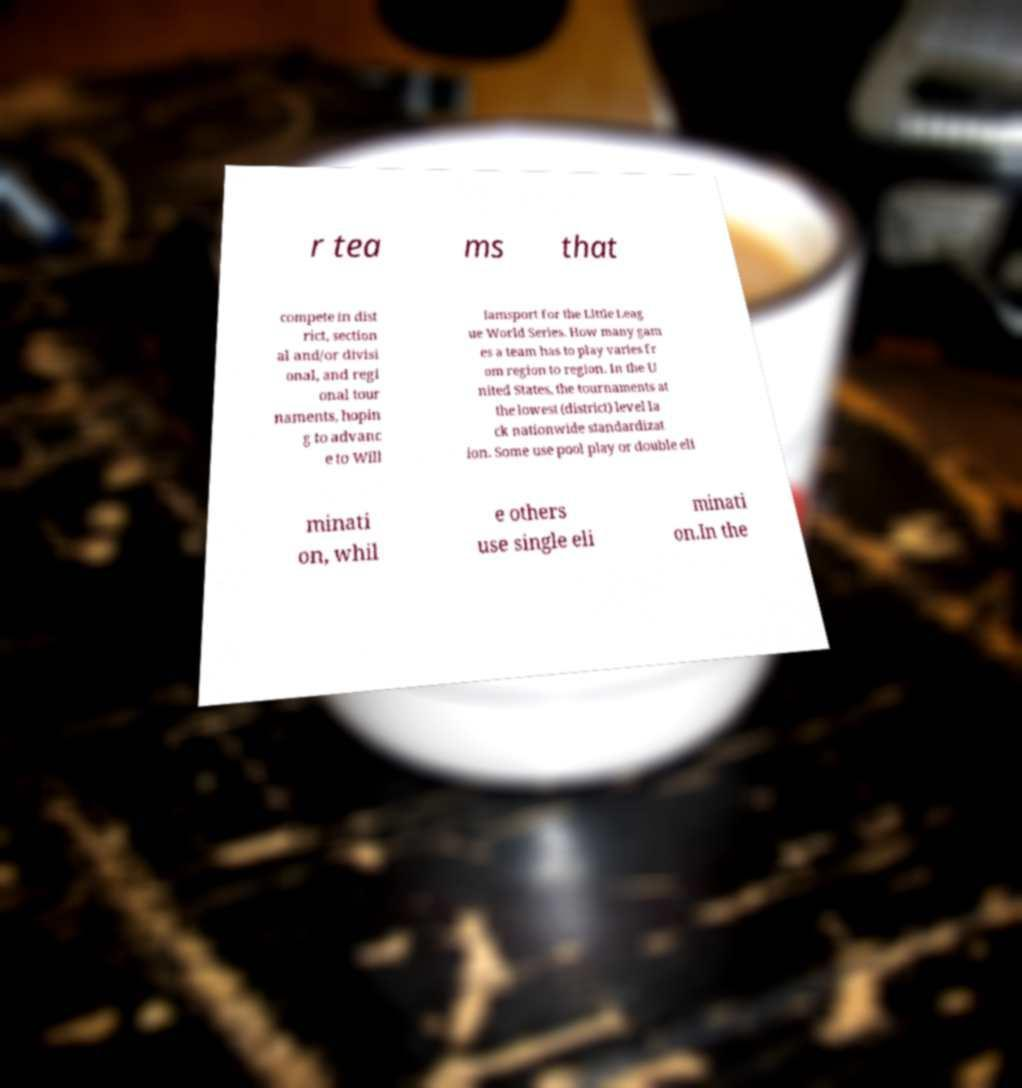Can you accurately transcribe the text from the provided image for me? r tea ms that compete in dist rict, section al and/or divisi onal, and regi onal tour naments, hopin g to advanc e to Will iamsport for the Little Leag ue World Series. How many gam es a team has to play varies fr om region to region. In the U nited States, the tournaments at the lowest (district) level la ck nationwide standardizat ion. Some use pool play or double eli minati on, whil e others use single eli minati on.In the 